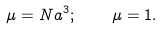Convert formula to latex. <formula><loc_0><loc_0><loc_500><loc_500>\mu = N a ^ { 3 } ; \quad \mu = 1 .</formula> 